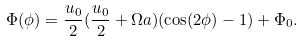<formula> <loc_0><loc_0><loc_500><loc_500>\Phi ( \phi ) = \frac { u _ { 0 } } { 2 } ( \frac { u _ { 0 } } { 2 } + \Omega a ) ( \cos ( 2 \phi ) - 1 ) + \Phi _ { 0 } .</formula> 